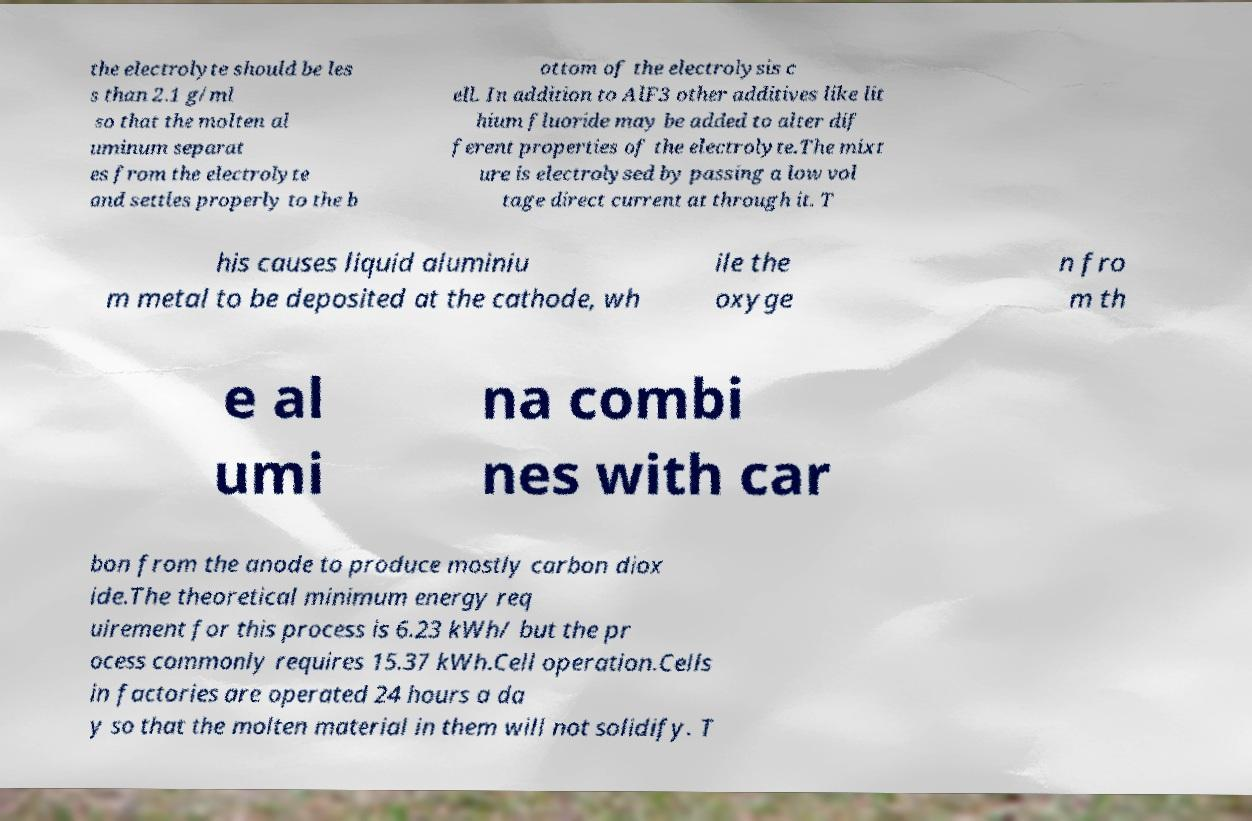I need the written content from this picture converted into text. Can you do that? the electrolyte should be les s than 2.1 g/ml so that the molten al uminum separat es from the electrolyte and settles properly to the b ottom of the electrolysis c ell. In addition to AlF3 other additives like lit hium fluoride may be added to alter dif ferent properties of the electrolyte.The mixt ure is electrolysed by passing a low vol tage direct current at through it. T his causes liquid aluminiu m metal to be deposited at the cathode, wh ile the oxyge n fro m th e al umi na combi nes with car bon from the anode to produce mostly carbon diox ide.The theoretical minimum energy req uirement for this process is 6.23 kWh/ but the pr ocess commonly requires 15.37 kWh.Cell operation.Cells in factories are operated 24 hours a da y so that the molten material in them will not solidify. T 